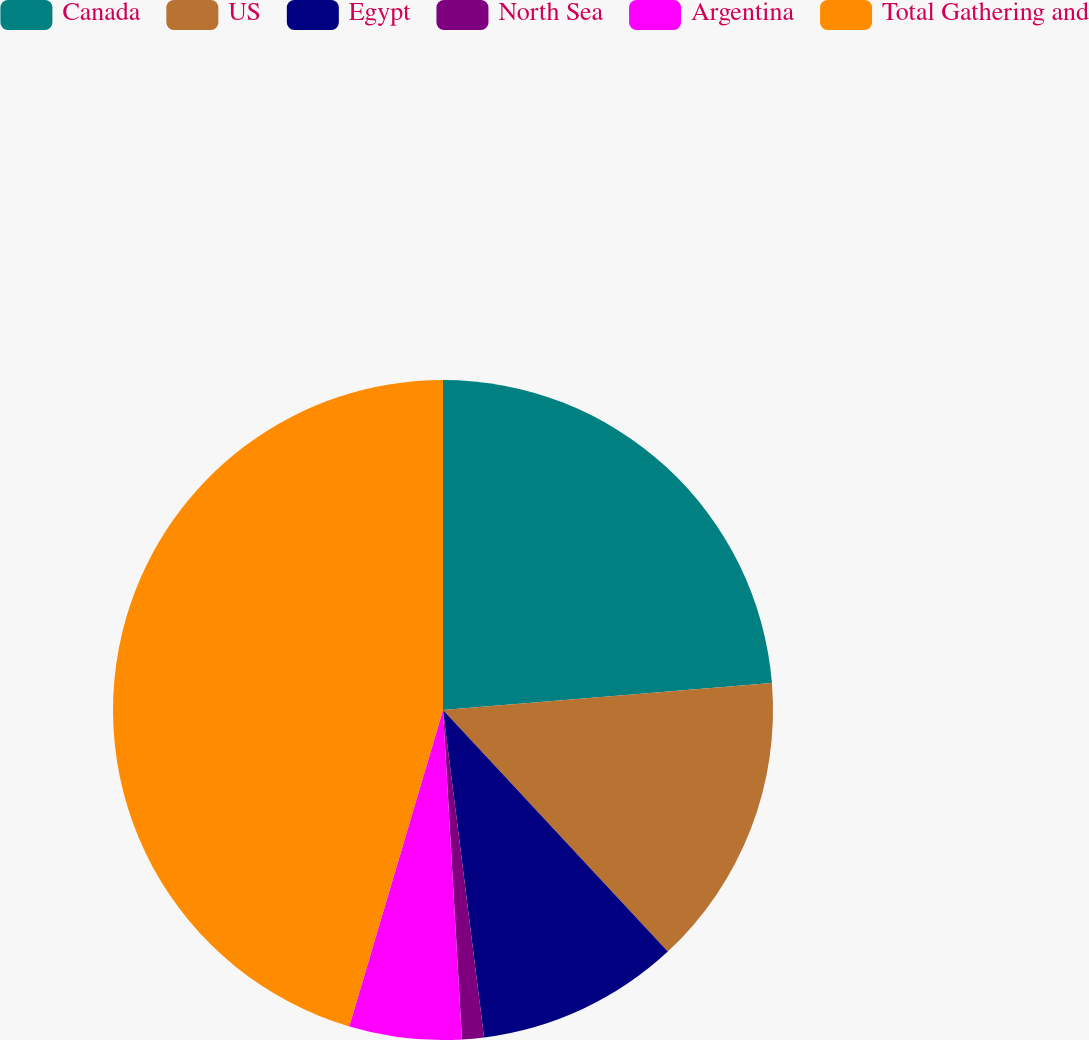Convert chart to OTSL. <chart><loc_0><loc_0><loc_500><loc_500><pie_chart><fcel>Canada<fcel>US<fcel>Egypt<fcel>North Sea<fcel>Argentina<fcel>Total Gathering and<nl><fcel>23.7%<fcel>14.37%<fcel>9.94%<fcel>1.07%<fcel>5.5%<fcel>45.41%<nl></chart> 